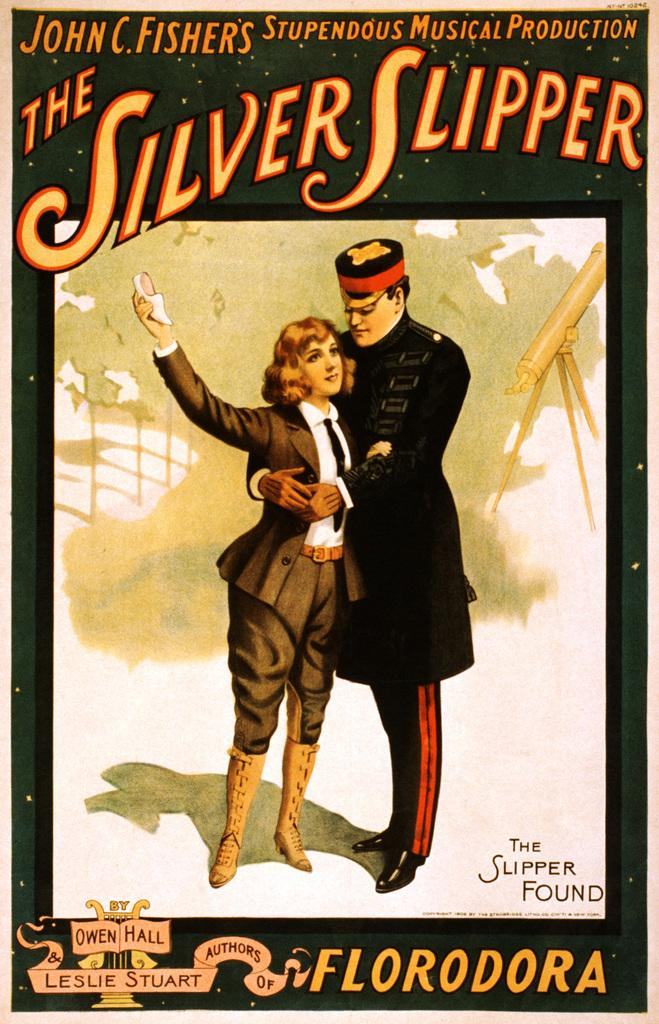<image>
Share a concise interpretation of the image provided. An old poster of "the Silver Slipper" musical shows the female and male character in costumes. 